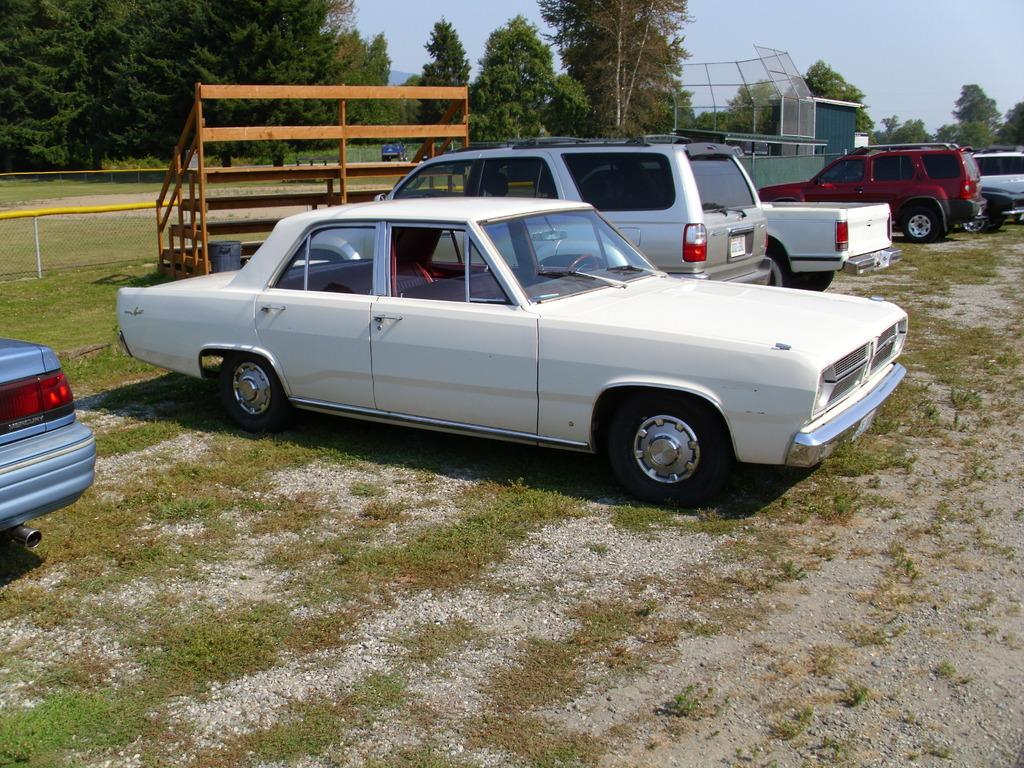What types of objects are on the ground in the image? There are vehicles on the ground in the image. What natural elements can be seen in the image? There are trees visible in the image. What type of structure is present in the image? There are wooden stairs in the image. What color is the sky in the image? The sky is blue in the image. Can you see a beetle crawling on the roof in the image? There is no roof or beetle present in the image. Are the people in the image kissing each other? There are no people visible in the image. 